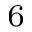<formula> <loc_0><loc_0><loc_500><loc_500>^ { 6 }</formula> 